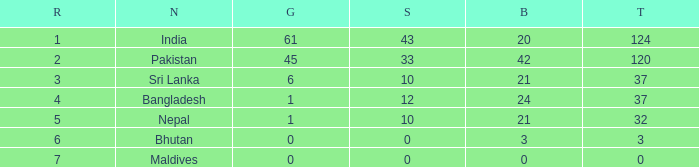Which Silver has a Rank of 6, and a Bronze smaller than 3? None. 